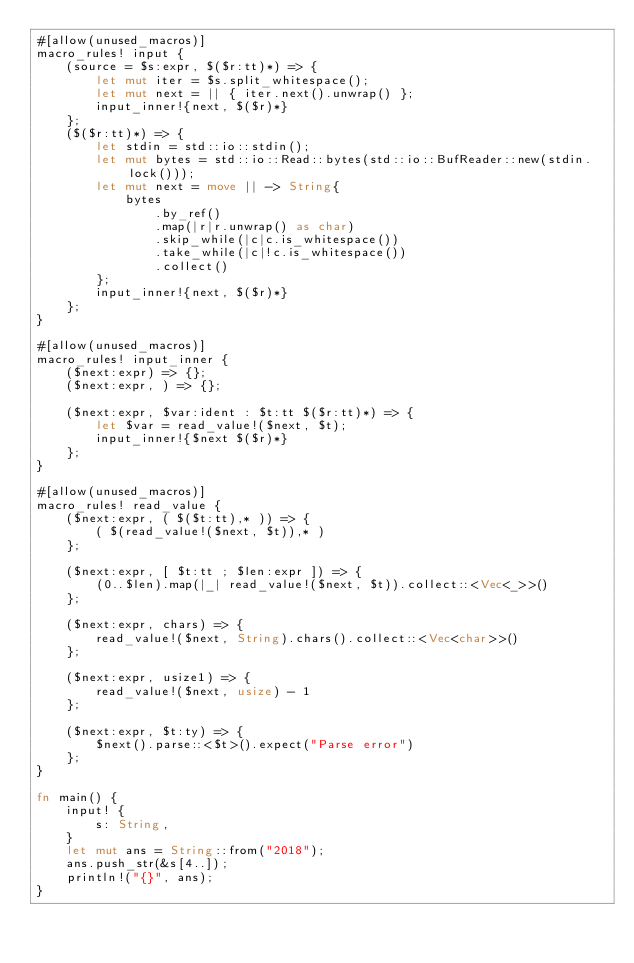Convert code to text. <code><loc_0><loc_0><loc_500><loc_500><_Rust_>#[allow(unused_macros)]
macro_rules! input {
    (source = $s:expr, $($r:tt)*) => {
        let mut iter = $s.split_whitespace();
        let mut next = || { iter.next().unwrap() };
        input_inner!{next, $($r)*}
    };
    ($($r:tt)*) => {
        let stdin = std::io::stdin();
        let mut bytes = std::io::Read::bytes(std::io::BufReader::new(stdin.lock()));
        let mut next = move || -> String{
            bytes
                .by_ref()
                .map(|r|r.unwrap() as char)
                .skip_while(|c|c.is_whitespace())
                .take_while(|c|!c.is_whitespace())
                .collect()
        };
        input_inner!{next, $($r)*}
    };
}

#[allow(unused_macros)]
macro_rules! input_inner {
    ($next:expr) => {};
    ($next:expr, ) => {};

    ($next:expr, $var:ident : $t:tt $($r:tt)*) => {
        let $var = read_value!($next, $t);
        input_inner!{$next $($r)*}
    };
}

#[allow(unused_macros)]
macro_rules! read_value {
    ($next:expr, ( $($t:tt),* )) => {
        ( $(read_value!($next, $t)),* )
    };

    ($next:expr, [ $t:tt ; $len:expr ]) => {
        (0..$len).map(|_| read_value!($next, $t)).collect::<Vec<_>>()
    };

    ($next:expr, chars) => {
        read_value!($next, String).chars().collect::<Vec<char>>()
    };

    ($next:expr, usize1) => {
        read_value!($next, usize) - 1
    };

    ($next:expr, $t:ty) => {
        $next().parse::<$t>().expect("Parse error")
    };
}

fn main() {
    input! {
        s: String,
    }
    let mut ans = String::from("2018");
    ans.push_str(&s[4..]);
    println!("{}", ans);
}
</code> 